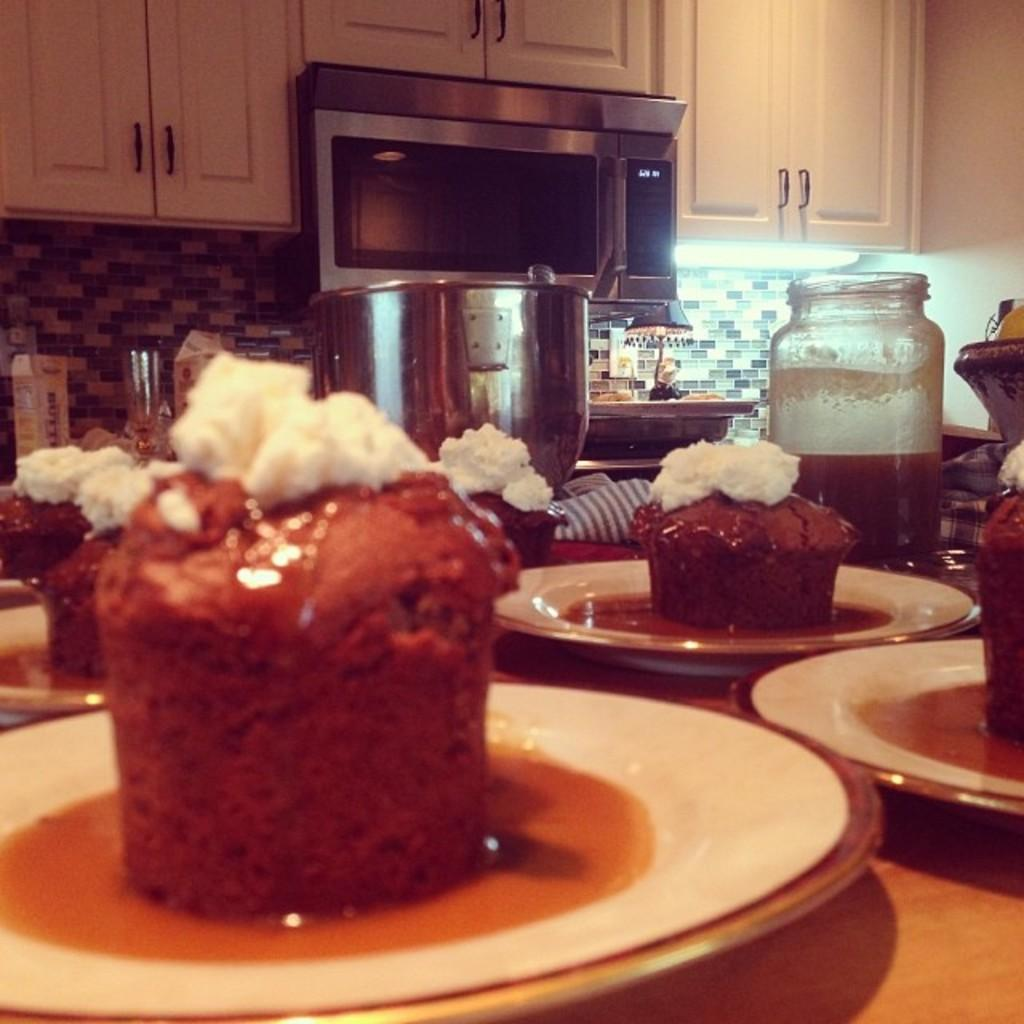What is on the plates in the image? There is food in the plates in the image. What is located beside the plate in the image? There is a jar and a bowl beside the plate in the image. What can be seen in the background of the image? There is a microwave oven, a light, and packets in the background of the image. What type of bell can be heard ringing in the image? There is no bell present in the image, and therefore no sound can be heard. 